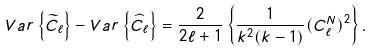<formula> <loc_0><loc_0><loc_500><loc_500>V a r \left \{ \widetilde { C } _ { \ell } \right \} - V a r \left \{ \widehat { C } _ { \ell } \right \} = \frac { 2 } { 2 \ell + 1 } \left \{ \frac { 1 } { k ^ { 2 } ( k - 1 ) } ( C _ { \ell } ^ { N } ) ^ { 2 } \right \} .</formula> 